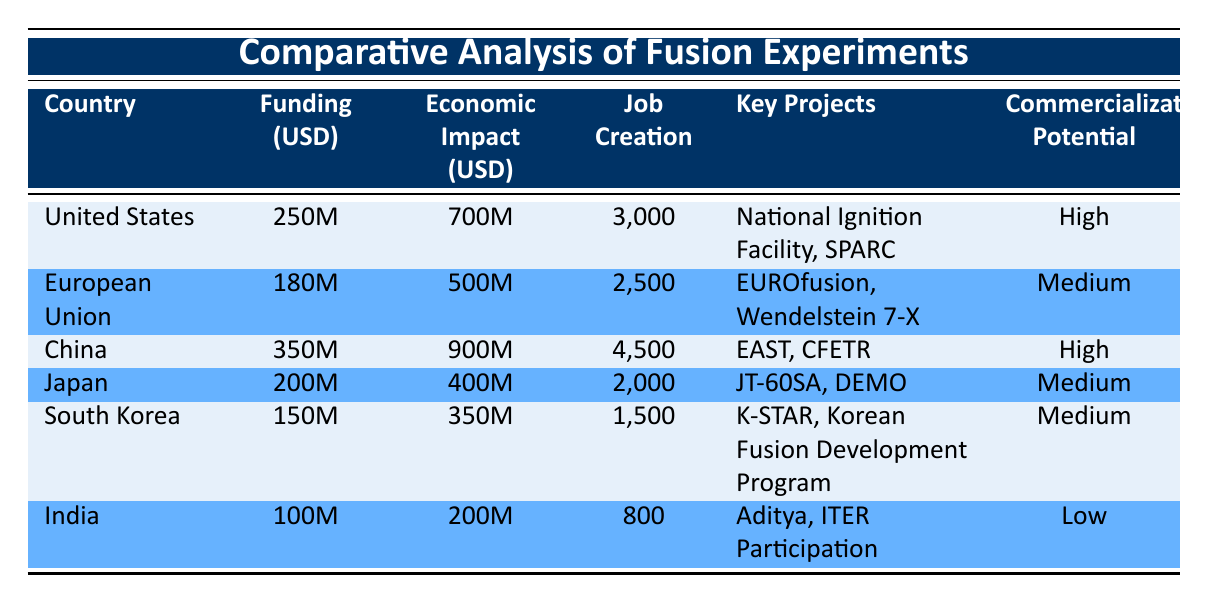What is the economic impact of fusion experiments in China? The economic impact listed for China in the table is directly available in the Economic Impact column. China has an economic impact of 900 million USD.
Answer: 900 million USD Which country created the most jobs through fusion experiments? The Job Creation column indicates the number of jobs created by each country. China has the highest number at 4,500 jobs created, more than any other country listed.
Answer: China What is the total funding amount for all countries combined? To find the total funding amount, sum the Funding Amounts from each country: 250M + 180M + 350M + 200M + 150M + 100M = 1,330M, or 1.33 billion USD.
Answer: 1.33 billion USD Is the commercialization potential for fusion experiments in the United States high? Referring to the Commercialization Potential column for the United States shows that it is labeled as "High." Therefore, the statement is true.
Answer: Yes Which two countries have a medium commercialization potential? To identify the countries with medium commercialization potential, check the Commercialization Potential column and filter for "Medium." The two countries listed are the European Union and Japan.
Answer: European Union and Japan What is the difference in economic impact between the United States and India? To find the difference, subtract India's economic impact from that of the United States: 700M (US) - 200M (India) = 500M.
Answer: 500 million USD Which research institutions are associated with China's fusion experiments? The Research Institutions column for China lists the associated institutions as the Southwestern Institute of Physics and the Institute of Plasma Physics.
Answer: Southwestern Institute of Physics, Institute of Plasma Physics How many total jobs were created in the European Union and South Korea combined? To find this, add the Job Creation numbers for both regions: 2,500 (EU) + 1,500 (South Korea) = 4,000 jobs.
Answer: 4,000 jobs What is the key project for Japan mentioned in the table? The Key Projects column for Japan lists both JT-60SA and DEMO, indicating these are the projects associated with Japan's fusion experiments.
Answer: JT-60SA, DEMO 